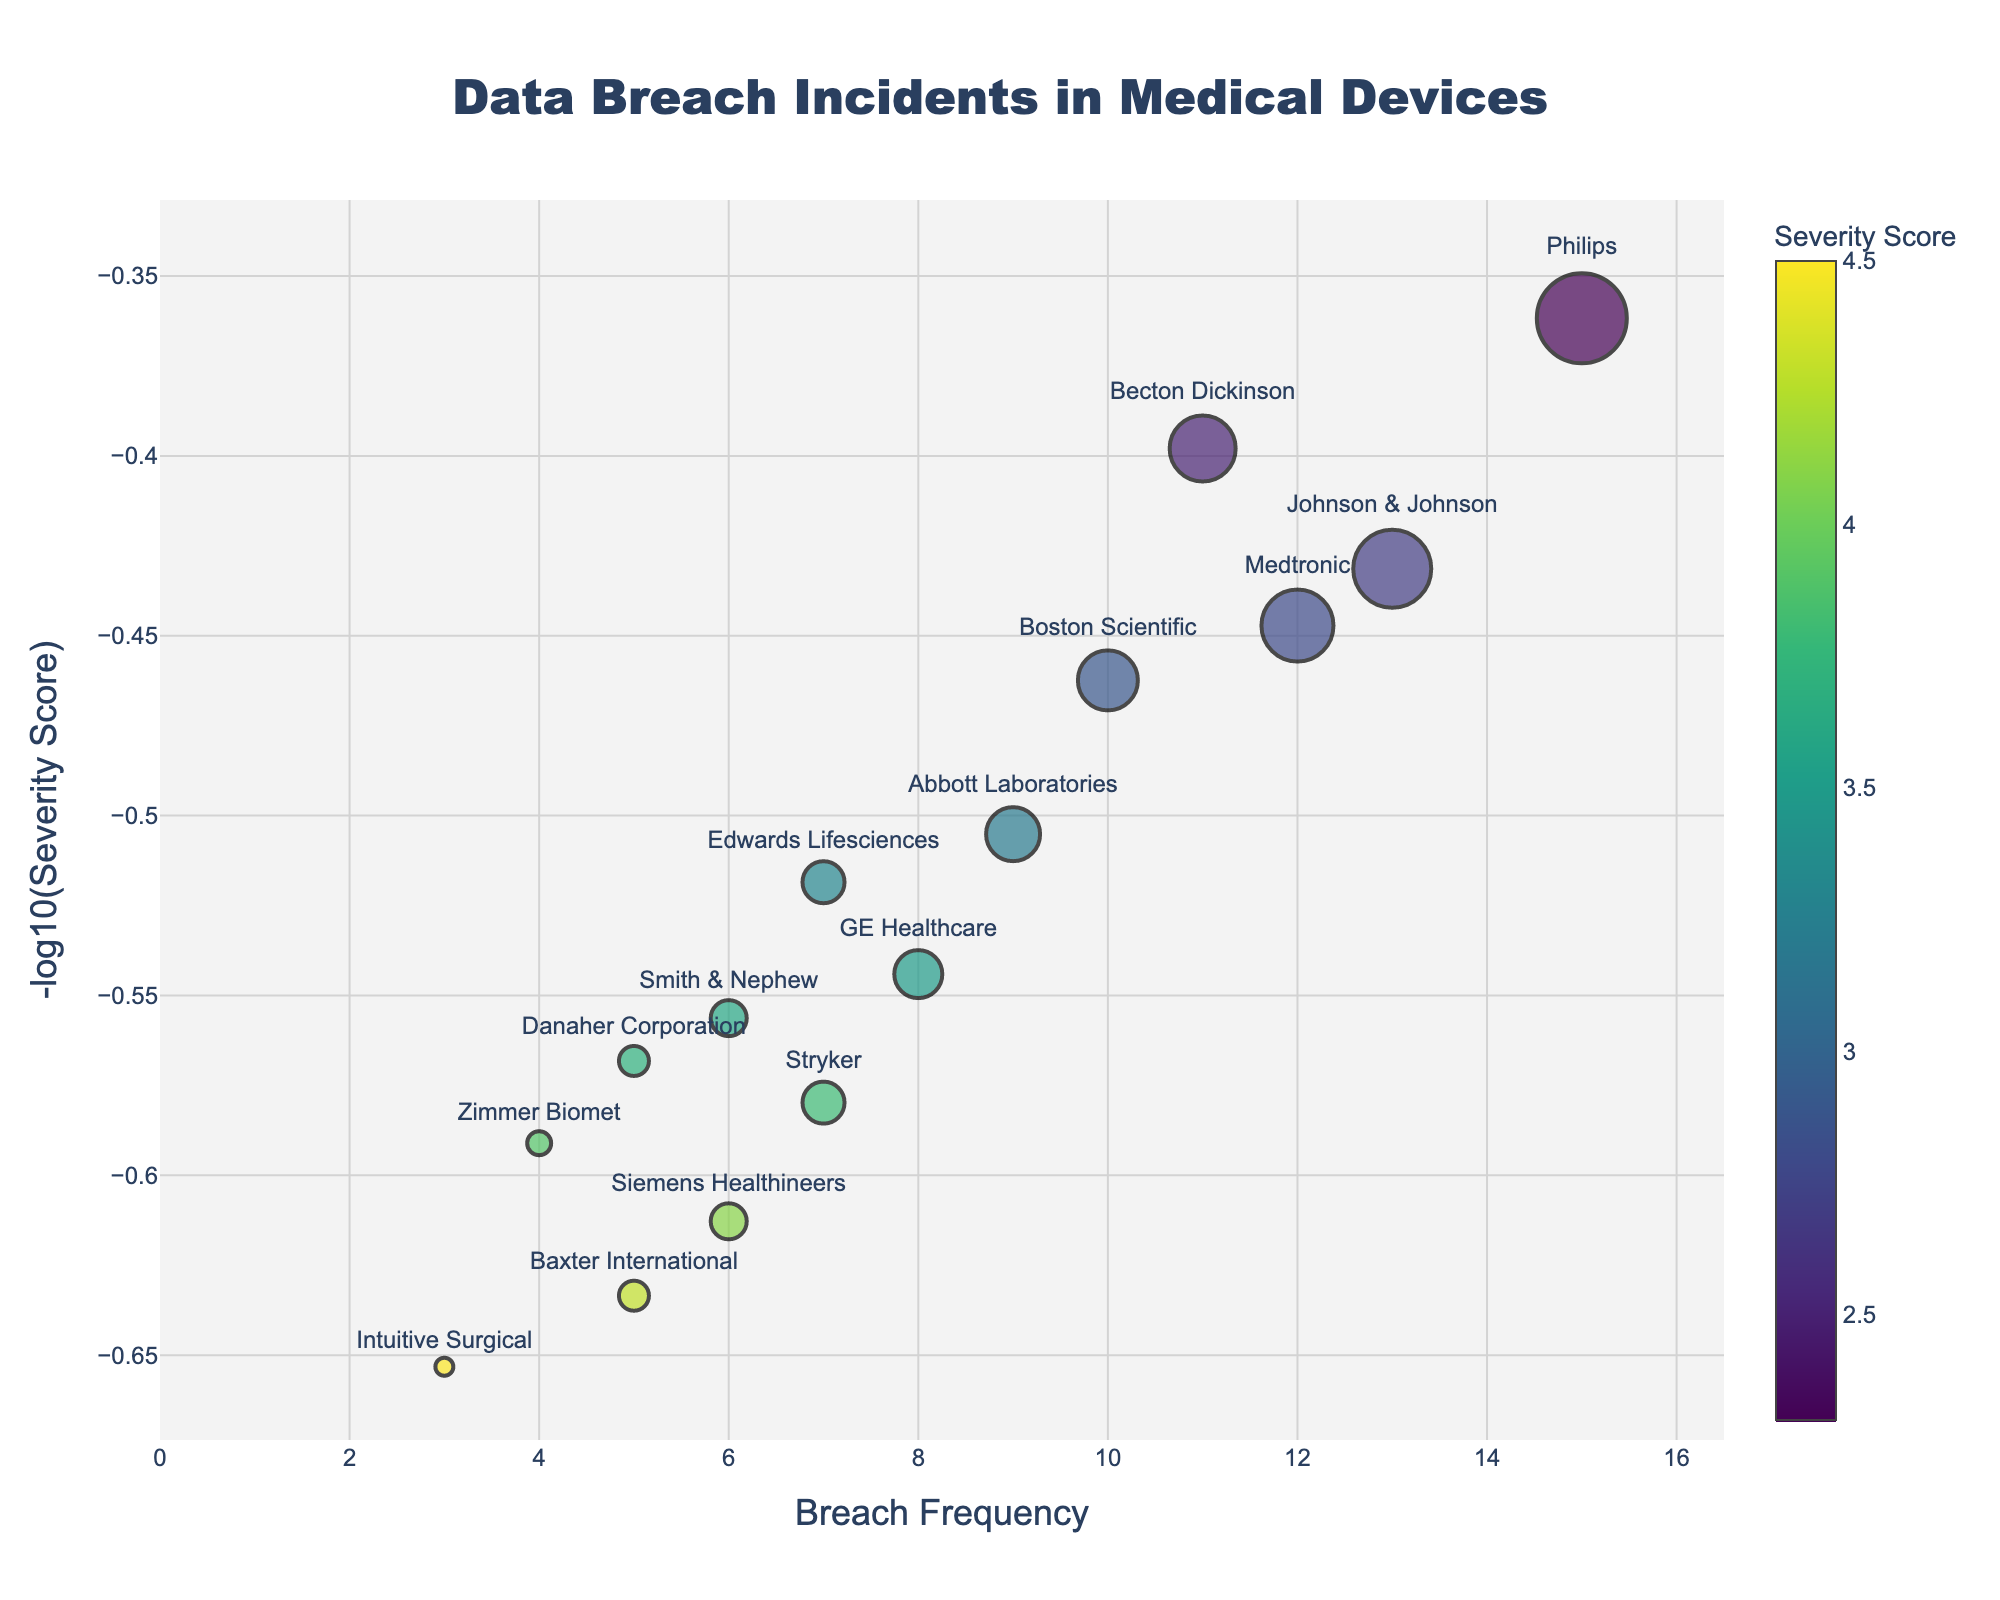What is the title of the Volcano Plot? The title is placed at the top of the plot, indicating the purpose and content of the visualization.
Answer: Data Breach Incidents in Medical Devices Which manufacturer has the highest breach frequency? The highest breach frequency can be identified by looking at the x-axis where the data point is farthest to the right.
Answer: Philips What is the color scale representing in the figure? The color scale, represented by the color bar on the right side of the plot, shows the Severity Score of the breaches. Darker colors indicate higher severity scores.
Answer: Severity Score Which manufacturer has the highest severity score? We can find the manufacturer with the highest severity score by looking at the color scale and finding the darkest colored data point.
Answer: Intuitive Surgical How many manufacturers have a breach frequency of 10 or more? Count the manufacturers whose data points are located at frequency 10 or greater along the x-axis.
Answer: 4 (Medtronic, Philips, Boston Scientific, Johnson & Johnson) Which data point is positioned at (-log10 Severity Score) of around -0.6? The y-axis represents the negative log10 of the Severity Score. Locate the data point closest to -0.6 on the y-axis.
Answer: Abbott Laboratories Compare the breach frequencies of Medtronic and Siemens Healthineers and identify which is higher. Locate the data points for Medtronic and Siemens Healthineers on the x-axis and compare their positions.
Answer: Medtronic Which manufacturer has the smallest breach frequency but one of the highest severity scores? Identify the data point with the smallest x-position then check its color for high severity values.
Answer: Intuitive Surgical What pattern can you observe in the relationship between breach frequency and severity score? Observe the general trends in the data points, noting any visible patterns or correlations between x (frequency) and color (severity score).
Answer: No clear pattern; severity scores vary regardless of frequency Calculate the average breach frequency for manufacturers with a severity score less than 3. Identify manufacturers with severity scores less than 3, sum their breach frequencies, and divide by the number of such manufacturers. (Medtronic, Philips, Becton Dickinson, Johnson & Johnson) (12 + 15 + 11 + 13) / 4 = 12.75
Answer: 12.75 